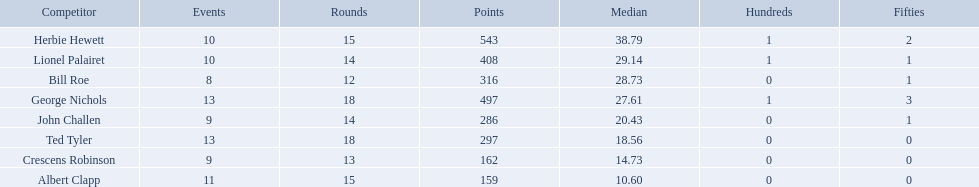Who are all of the players? Herbie Hewett, Lionel Palairet, Bill Roe, George Nichols, John Challen, Ted Tyler, Crescens Robinson, Albert Clapp. How many innings did they play in? 15, 14, 12, 18, 14, 18, 13, 15. Parse the full table in json format. {'header': ['Competitor', 'Events', 'Rounds', 'Points', 'Median', 'Hundreds', 'Fifties'], 'rows': [['Herbie Hewett', '10', '15', '543', '38.79', '1', '2'], ['Lionel Palairet', '10', '14', '408', '29.14', '1', '1'], ['Bill Roe', '8', '12', '316', '28.73', '0', '1'], ['George Nichols', '13', '18', '497', '27.61', '1', '3'], ['John Challen', '9', '14', '286', '20.43', '0', '1'], ['Ted Tyler', '13', '18', '297', '18.56', '0', '0'], ['Crescens Robinson', '9', '13', '162', '14.73', '0', '0'], ['Albert Clapp', '11', '15', '159', '10.60', '0', '0']]} Which player was in fewer than 13 innings? Bill Roe. Who are the players in somerset county cricket club in 1890? Herbie Hewett, Lionel Palairet, Bill Roe, George Nichols, John Challen, Ted Tyler, Crescens Robinson, Albert Clapp. Who is the only player to play less than 13 innings? Bill Roe. Which players played in 10 or fewer matches? Herbie Hewett, Lionel Palairet, Bill Roe, John Challen, Crescens Robinson. Of these, which played in only 12 innings? Bill Roe. 